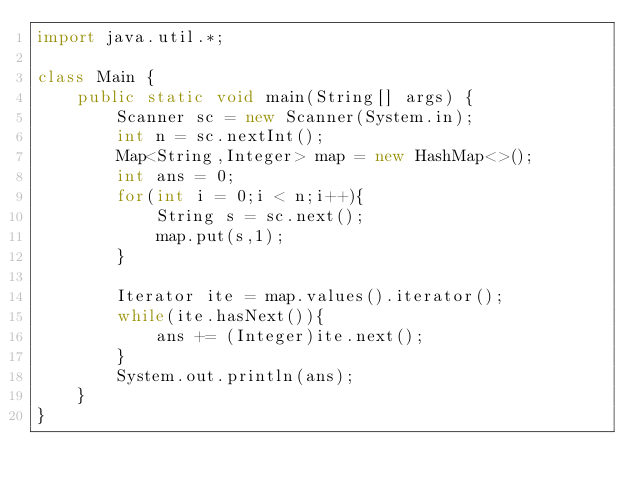<code> <loc_0><loc_0><loc_500><loc_500><_Java_>import java.util.*;

class Main {
    public static void main(String[] args) {
        Scanner sc = new Scanner(System.in);
        int n = sc.nextInt();
        Map<String,Integer> map = new HashMap<>();
        int ans = 0;
        for(int i = 0;i < n;i++){
            String s = sc.next();
            map.put(s,1);
        }

        Iterator ite = map.values().iterator();
        while(ite.hasNext()){
            ans += (Integer)ite.next();
        }
        System.out.println(ans);
    }
}</code> 